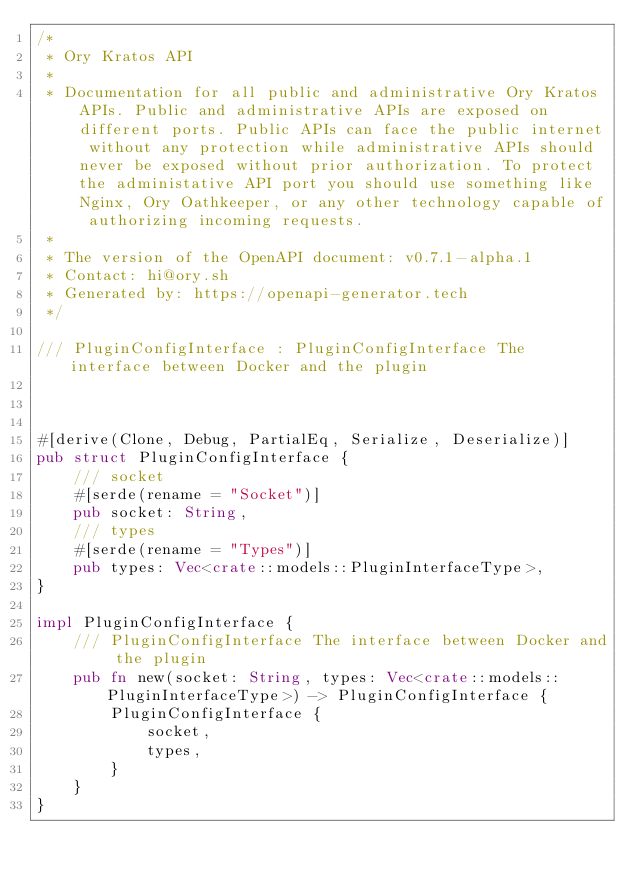Convert code to text. <code><loc_0><loc_0><loc_500><loc_500><_Rust_>/*
 * Ory Kratos API
 *
 * Documentation for all public and administrative Ory Kratos APIs. Public and administrative APIs are exposed on different ports. Public APIs can face the public internet without any protection while administrative APIs should never be exposed without prior authorization. To protect the administative API port you should use something like Nginx, Ory Oathkeeper, or any other technology capable of authorizing incoming requests. 
 *
 * The version of the OpenAPI document: v0.7.1-alpha.1
 * Contact: hi@ory.sh
 * Generated by: https://openapi-generator.tech
 */

/// PluginConfigInterface : PluginConfigInterface The interface between Docker and the plugin



#[derive(Clone, Debug, PartialEq, Serialize, Deserialize)]
pub struct PluginConfigInterface {
    /// socket
    #[serde(rename = "Socket")]
    pub socket: String,
    /// types
    #[serde(rename = "Types")]
    pub types: Vec<crate::models::PluginInterfaceType>,
}

impl PluginConfigInterface {
    /// PluginConfigInterface The interface between Docker and the plugin
    pub fn new(socket: String, types: Vec<crate::models::PluginInterfaceType>) -> PluginConfigInterface {
        PluginConfigInterface {
            socket,
            types,
        }
    }
}


</code> 